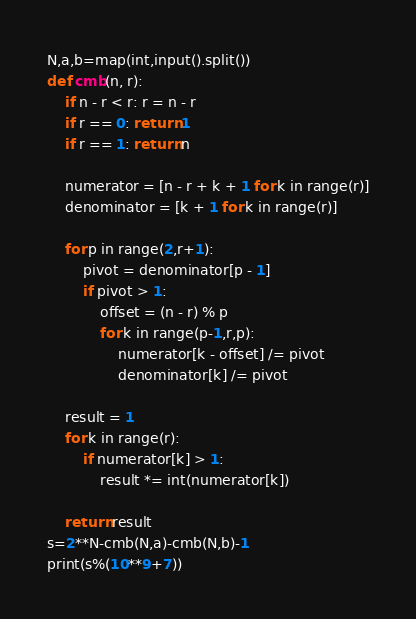Convert code to text. <code><loc_0><loc_0><loc_500><loc_500><_Python_>N,a,b=map(int,input().split())
def cmb(n, r):
    if n - r < r: r = n - r
    if r == 0: return 1
    if r == 1: return n

    numerator = [n - r + k + 1 for k in range(r)]
    denominator = [k + 1 for k in range(r)]

    for p in range(2,r+1):
        pivot = denominator[p - 1]
        if pivot > 1:
            offset = (n - r) % p
            for k in range(p-1,r,p):
                numerator[k - offset] /= pivot
                denominator[k] /= pivot

    result = 1
    for k in range(r):
        if numerator[k] > 1:
            result *= int(numerator[k])

    return result
s=2**N-cmb(N,a)-cmb(N,b)-1
print(s%(10**9+7))</code> 